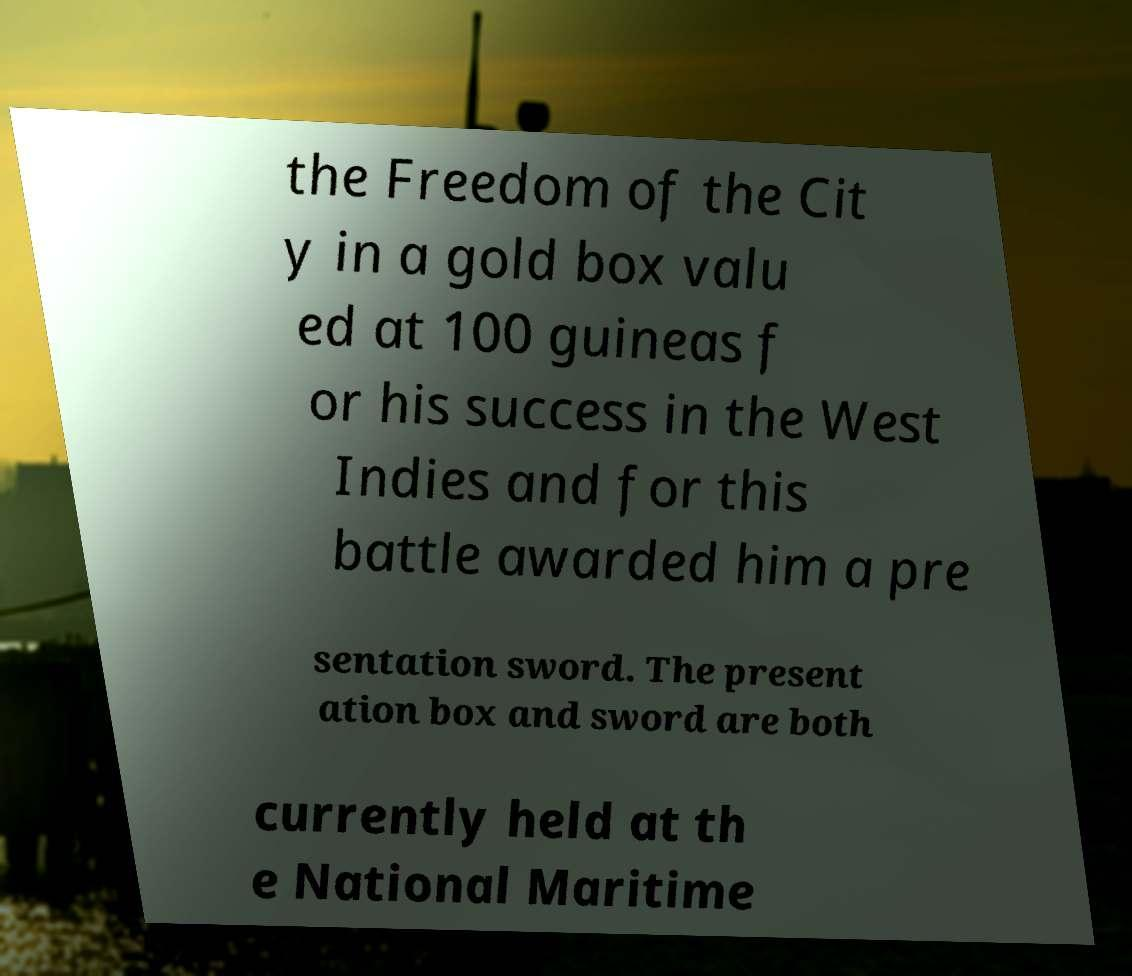What messages or text are displayed in this image? I need them in a readable, typed format. the Freedom of the Cit y in a gold box valu ed at 100 guineas f or his success in the West Indies and for this battle awarded him a pre sentation sword. The present ation box and sword are both currently held at th e National Maritime 